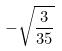Convert formula to latex. <formula><loc_0><loc_0><loc_500><loc_500>- \sqrt { \frac { 3 } { 3 5 } }</formula> 